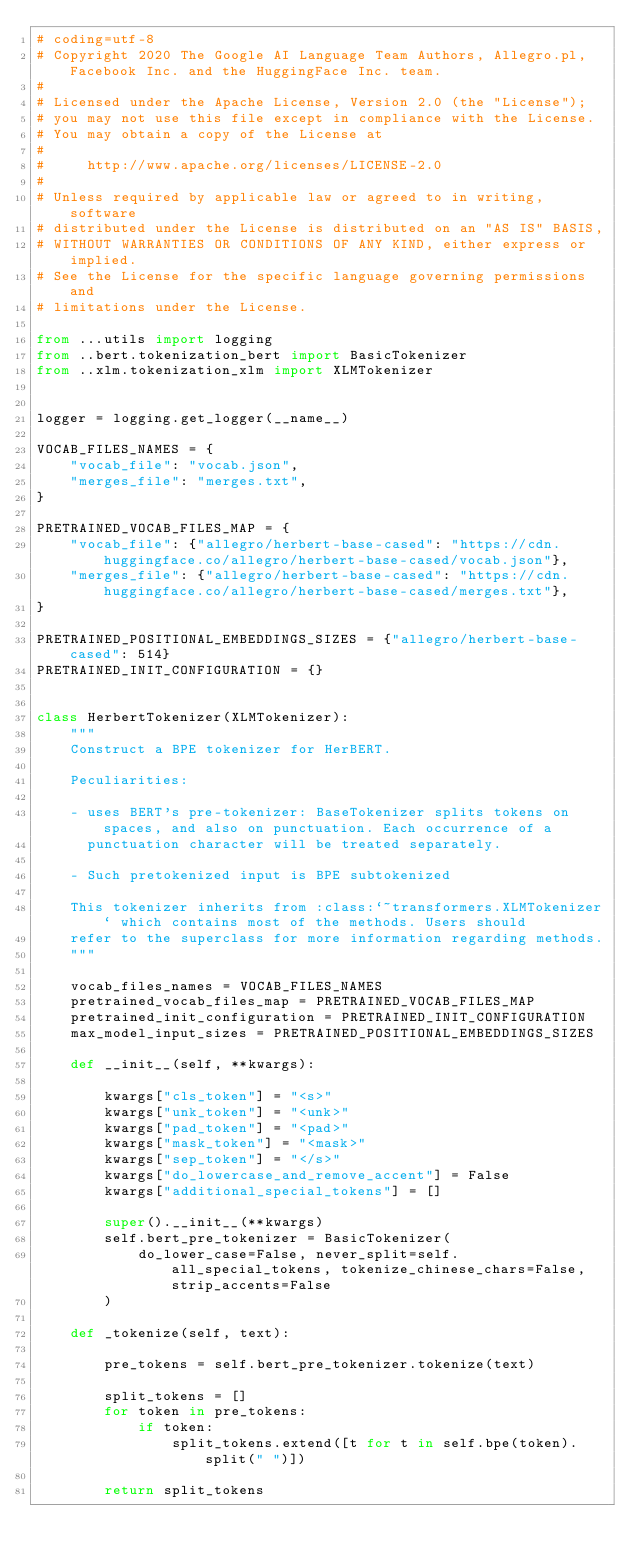Convert code to text. <code><loc_0><loc_0><loc_500><loc_500><_Python_># coding=utf-8
# Copyright 2020 The Google AI Language Team Authors, Allegro.pl, Facebook Inc. and the HuggingFace Inc. team.
#
# Licensed under the Apache License, Version 2.0 (the "License");
# you may not use this file except in compliance with the License.
# You may obtain a copy of the License at
#
#     http://www.apache.org/licenses/LICENSE-2.0
#
# Unless required by applicable law or agreed to in writing, software
# distributed under the License is distributed on an "AS IS" BASIS,
# WITHOUT WARRANTIES OR CONDITIONS OF ANY KIND, either express or implied.
# See the License for the specific language governing permissions and
# limitations under the License.

from ...utils import logging
from ..bert.tokenization_bert import BasicTokenizer
from ..xlm.tokenization_xlm import XLMTokenizer


logger = logging.get_logger(__name__)

VOCAB_FILES_NAMES = {
    "vocab_file": "vocab.json",
    "merges_file": "merges.txt",
}

PRETRAINED_VOCAB_FILES_MAP = {
    "vocab_file": {"allegro/herbert-base-cased": "https://cdn.huggingface.co/allegro/herbert-base-cased/vocab.json"},
    "merges_file": {"allegro/herbert-base-cased": "https://cdn.huggingface.co/allegro/herbert-base-cased/merges.txt"},
}

PRETRAINED_POSITIONAL_EMBEDDINGS_SIZES = {"allegro/herbert-base-cased": 514}
PRETRAINED_INIT_CONFIGURATION = {}


class HerbertTokenizer(XLMTokenizer):
    """
    Construct a BPE tokenizer for HerBERT.

    Peculiarities:

    - uses BERT's pre-tokenizer: BaseTokenizer splits tokens on spaces, and also on punctuation. Each occurrence of a
      punctuation character will be treated separately.

    - Such pretokenized input is BPE subtokenized

    This tokenizer inherits from :class:`~transformers.XLMTokenizer` which contains most of the methods. Users should
    refer to the superclass for more information regarding methods.
    """

    vocab_files_names = VOCAB_FILES_NAMES
    pretrained_vocab_files_map = PRETRAINED_VOCAB_FILES_MAP
    pretrained_init_configuration = PRETRAINED_INIT_CONFIGURATION
    max_model_input_sizes = PRETRAINED_POSITIONAL_EMBEDDINGS_SIZES

    def __init__(self, **kwargs):

        kwargs["cls_token"] = "<s>"
        kwargs["unk_token"] = "<unk>"
        kwargs["pad_token"] = "<pad>"
        kwargs["mask_token"] = "<mask>"
        kwargs["sep_token"] = "</s>"
        kwargs["do_lowercase_and_remove_accent"] = False
        kwargs["additional_special_tokens"] = []

        super().__init__(**kwargs)
        self.bert_pre_tokenizer = BasicTokenizer(
            do_lower_case=False, never_split=self.all_special_tokens, tokenize_chinese_chars=False, strip_accents=False
        )

    def _tokenize(self, text):

        pre_tokens = self.bert_pre_tokenizer.tokenize(text)

        split_tokens = []
        for token in pre_tokens:
            if token:
                split_tokens.extend([t for t in self.bpe(token).split(" ")])

        return split_tokens
</code> 